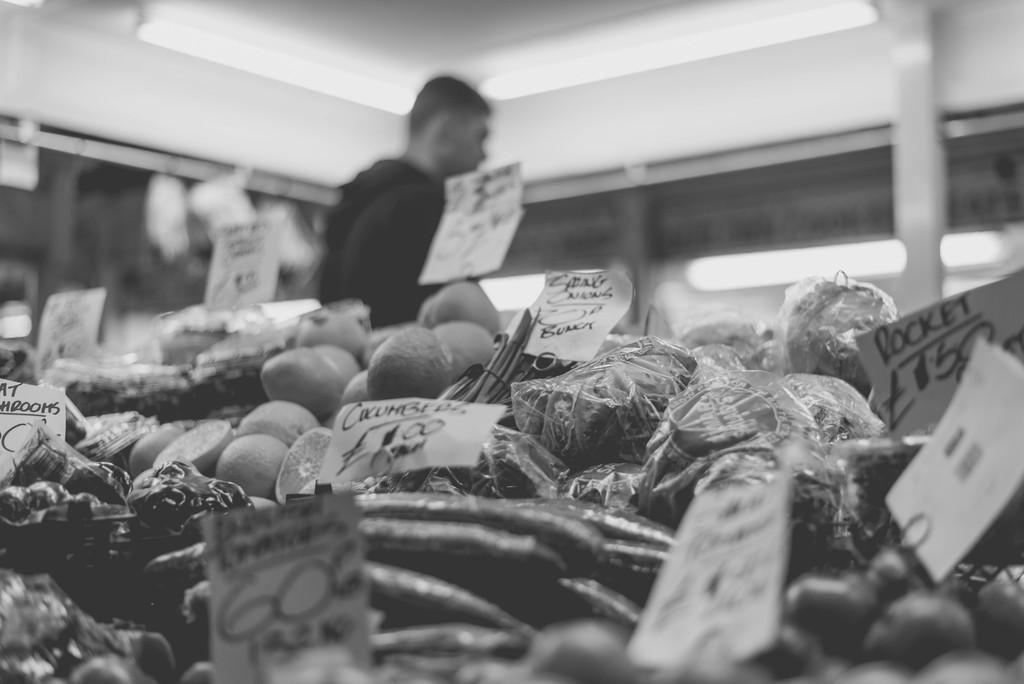In one or two sentences, can you explain what this image depicts? In the center of the image we can see different types of vegetables with price tags. In the background there is a wall, one person is standing and a few other objects. 